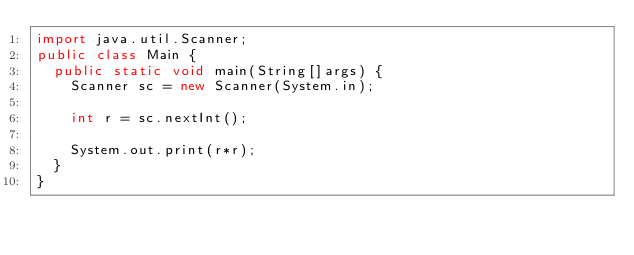<code> <loc_0><loc_0><loc_500><loc_500><_Java_>import java.util.Scanner;
public class Main {
	public static void main(String[]args) {
		Scanner sc = new Scanner(System.in);

		int r = sc.nextInt();

		System.out.print(r*r);
	}
}
</code> 